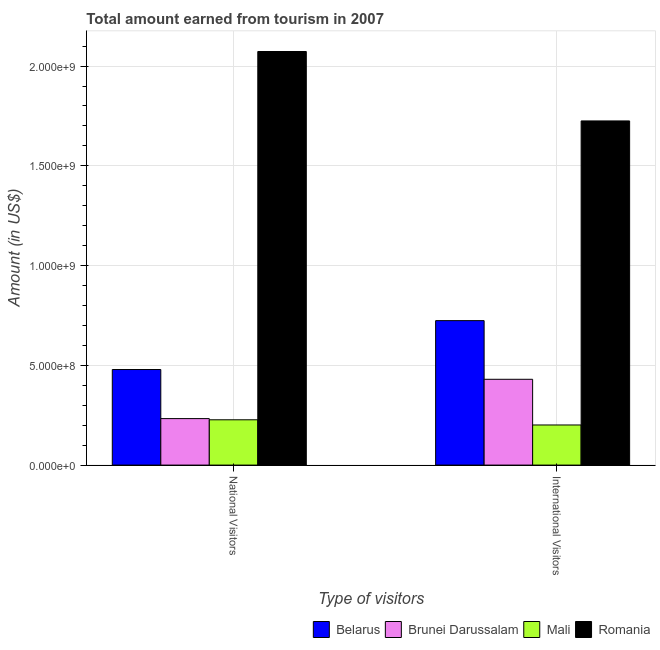How many groups of bars are there?
Keep it short and to the point. 2. Are the number of bars per tick equal to the number of legend labels?
Offer a terse response. Yes. Are the number of bars on each tick of the X-axis equal?
Ensure brevity in your answer.  Yes. How many bars are there on the 2nd tick from the left?
Provide a succinct answer. 4. What is the label of the 1st group of bars from the left?
Your response must be concise. National Visitors. What is the amount earned from international visitors in Brunei Darussalam?
Offer a very short reply. 4.30e+08. Across all countries, what is the maximum amount earned from national visitors?
Make the answer very short. 2.07e+09. Across all countries, what is the minimum amount earned from international visitors?
Ensure brevity in your answer.  2.01e+08. In which country was the amount earned from international visitors maximum?
Offer a terse response. Romania. In which country was the amount earned from international visitors minimum?
Offer a very short reply. Mali. What is the total amount earned from national visitors in the graph?
Your answer should be compact. 3.01e+09. What is the difference between the amount earned from international visitors in Belarus and that in Romania?
Your answer should be compact. -1.00e+09. What is the difference between the amount earned from international visitors in Romania and the amount earned from national visitors in Belarus?
Provide a short and direct response. 1.25e+09. What is the average amount earned from international visitors per country?
Keep it short and to the point. 7.70e+08. What is the difference between the amount earned from international visitors and amount earned from national visitors in Romania?
Offer a very short reply. -3.48e+08. What is the ratio of the amount earned from national visitors in Brunei Darussalam to that in Belarus?
Your answer should be very brief. 0.49. What does the 4th bar from the left in International Visitors represents?
Your answer should be compact. Romania. What does the 2nd bar from the right in International Visitors represents?
Provide a succinct answer. Mali. Are all the bars in the graph horizontal?
Give a very brief answer. No. Does the graph contain grids?
Give a very brief answer. Yes. Where does the legend appear in the graph?
Provide a short and direct response. Bottom right. How are the legend labels stacked?
Your response must be concise. Horizontal. What is the title of the graph?
Offer a terse response. Total amount earned from tourism in 2007. What is the label or title of the X-axis?
Provide a short and direct response. Type of visitors. What is the label or title of the Y-axis?
Your response must be concise. Amount (in US$). What is the Amount (in US$) in Belarus in National Visitors?
Provide a succinct answer. 4.79e+08. What is the Amount (in US$) in Brunei Darussalam in National Visitors?
Keep it short and to the point. 2.33e+08. What is the Amount (in US$) of Mali in National Visitors?
Provide a short and direct response. 2.27e+08. What is the Amount (in US$) of Romania in National Visitors?
Keep it short and to the point. 2.07e+09. What is the Amount (in US$) in Belarus in International Visitors?
Your answer should be very brief. 7.24e+08. What is the Amount (in US$) of Brunei Darussalam in International Visitors?
Offer a terse response. 4.30e+08. What is the Amount (in US$) in Mali in International Visitors?
Your response must be concise. 2.01e+08. What is the Amount (in US$) of Romania in International Visitors?
Provide a short and direct response. 1.72e+09. Across all Type of visitors, what is the maximum Amount (in US$) in Belarus?
Give a very brief answer. 7.24e+08. Across all Type of visitors, what is the maximum Amount (in US$) of Brunei Darussalam?
Your answer should be compact. 4.30e+08. Across all Type of visitors, what is the maximum Amount (in US$) in Mali?
Provide a short and direct response. 2.27e+08. Across all Type of visitors, what is the maximum Amount (in US$) of Romania?
Provide a short and direct response. 2.07e+09. Across all Type of visitors, what is the minimum Amount (in US$) in Belarus?
Make the answer very short. 4.79e+08. Across all Type of visitors, what is the minimum Amount (in US$) in Brunei Darussalam?
Give a very brief answer. 2.33e+08. Across all Type of visitors, what is the minimum Amount (in US$) in Mali?
Keep it short and to the point. 2.01e+08. Across all Type of visitors, what is the minimum Amount (in US$) of Romania?
Keep it short and to the point. 1.72e+09. What is the total Amount (in US$) of Belarus in the graph?
Give a very brief answer. 1.20e+09. What is the total Amount (in US$) of Brunei Darussalam in the graph?
Ensure brevity in your answer.  6.63e+08. What is the total Amount (in US$) in Mali in the graph?
Your answer should be very brief. 4.28e+08. What is the total Amount (in US$) in Romania in the graph?
Keep it short and to the point. 3.80e+09. What is the difference between the Amount (in US$) of Belarus in National Visitors and that in International Visitors?
Make the answer very short. -2.45e+08. What is the difference between the Amount (in US$) in Brunei Darussalam in National Visitors and that in International Visitors?
Your response must be concise. -1.97e+08. What is the difference between the Amount (in US$) of Mali in National Visitors and that in International Visitors?
Offer a very short reply. 2.60e+07. What is the difference between the Amount (in US$) in Romania in National Visitors and that in International Visitors?
Provide a succinct answer. 3.48e+08. What is the difference between the Amount (in US$) of Belarus in National Visitors and the Amount (in US$) of Brunei Darussalam in International Visitors?
Offer a very short reply. 4.90e+07. What is the difference between the Amount (in US$) in Belarus in National Visitors and the Amount (in US$) in Mali in International Visitors?
Offer a terse response. 2.78e+08. What is the difference between the Amount (in US$) of Belarus in National Visitors and the Amount (in US$) of Romania in International Visitors?
Your answer should be compact. -1.25e+09. What is the difference between the Amount (in US$) of Brunei Darussalam in National Visitors and the Amount (in US$) of Mali in International Visitors?
Provide a succinct answer. 3.20e+07. What is the difference between the Amount (in US$) of Brunei Darussalam in National Visitors and the Amount (in US$) of Romania in International Visitors?
Make the answer very short. -1.49e+09. What is the difference between the Amount (in US$) of Mali in National Visitors and the Amount (in US$) of Romania in International Visitors?
Keep it short and to the point. -1.50e+09. What is the average Amount (in US$) in Belarus per Type of visitors?
Your answer should be compact. 6.02e+08. What is the average Amount (in US$) of Brunei Darussalam per Type of visitors?
Give a very brief answer. 3.32e+08. What is the average Amount (in US$) of Mali per Type of visitors?
Offer a terse response. 2.14e+08. What is the average Amount (in US$) of Romania per Type of visitors?
Offer a terse response. 1.90e+09. What is the difference between the Amount (in US$) of Belarus and Amount (in US$) of Brunei Darussalam in National Visitors?
Give a very brief answer. 2.46e+08. What is the difference between the Amount (in US$) in Belarus and Amount (in US$) in Mali in National Visitors?
Give a very brief answer. 2.52e+08. What is the difference between the Amount (in US$) in Belarus and Amount (in US$) in Romania in National Visitors?
Offer a terse response. -1.59e+09. What is the difference between the Amount (in US$) in Brunei Darussalam and Amount (in US$) in Romania in National Visitors?
Your answer should be compact. -1.84e+09. What is the difference between the Amount (in US$) in Mali and Amount (in US$) in Romania in National Visitors?
Give a very brief answer. -1.85e+09. What is the difference between the Amount (in US$) in Belarus and Amount (in US$) in Brunei Darussalam in International Visitors?
Provide a succinct answer. 2.94e+08. What is the difference between the Amount (in US$) in Belarus and Amount (in US$) in Mali in International Visitors?
Provide a succinct answer. 5.23e+08. What is the difference between the Amount (in US$) in Belarus and Amount (in US$) in Romania in International Visitors?
Your answer should be compact. -1.00e+09. What is the difference between the Amount (in US$) in Brunei Darussalam and Amount (in US$) in Mali in International Visitors?
Your answer should be compact. 2.29e+08. What is the difference between the Amount (in US$) of Brunei Darussalam and Amount (in US$) of Romania in International Visitors?
Keep it short and to the point. -1.30e+09. What is the difference between the Amount (in US$) of Mali and Amount (in US$) of Romania in International Visitors?
Your answer should be very brief. -1.52e+09. What is the ratio of the Amount (in US$) in Belarus in National Visitors to that in International Visitors?
Give a very brief answer. 0.66. What is the ratio of the Amount (in US$) in Brunei Darussalam in National Visitors to that in International Visitors?
Your answer should be very brief. 0.54. What is the ratio of the Amount (in US$) of Mali in National Visitors to that in International Visitors?
Your response must be concise. 1.13. What is the ratio of the Amount (in US$) in Romania in National Visitors to that in International Visitors?
Provide a succinct answer. 1.2. What is the difference between the highest and the second highest Amount (in US$) of Belarus?
Give a very brief answer. 2.45e+08. What is the difference between the highest and the second highest Amount (in US$) in Brunei Darussalam?
Make the answer very short. 1.97e+08. What is the difference between the highest and the second highest Amount (in US$) in Mali?
Provide a succinct answer. 2.60e+07. What is the difference between the highest and the second highest Amount (in US$) in Romania?
Your answer should be very brief. 3.48e+08. What is the difference between the highest and the lowest Amount (in US$) in Belarus?
Give a very brief answer. 2.45e+08. What is the difference between the highest and the lowest Amount (in US$) in Brunei Darussalam?
Keep it short and to the point. 1.97e+08. What is the difference between the highest and the lowest Amount (in US$) in Mali?
Provide a short and direct response. 2.60e+07. What is the difference between the highest and the lowest Amount (in US$) of Romania?
Give a very brief answer. 3.48e+08. 